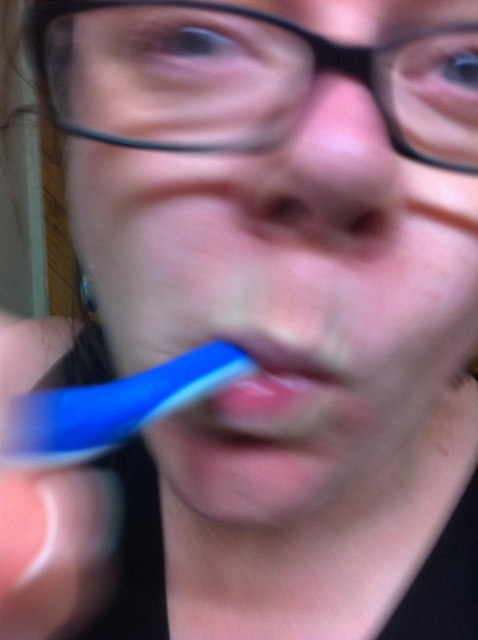Describe the objects in this image and their specific colors. I can see people in gray, lightpink, darkgray, and black tones and toothbrush in black, blue, gray, and darkgray tones in this image. 